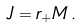<formula> <loc_0><loc_0><loc_500><loc_500>J = r _ { + } M \, .</formula> 